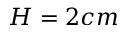<formula> <loc_0><loc_0><loc_500><loc_500>H = 2 c m</formula> 